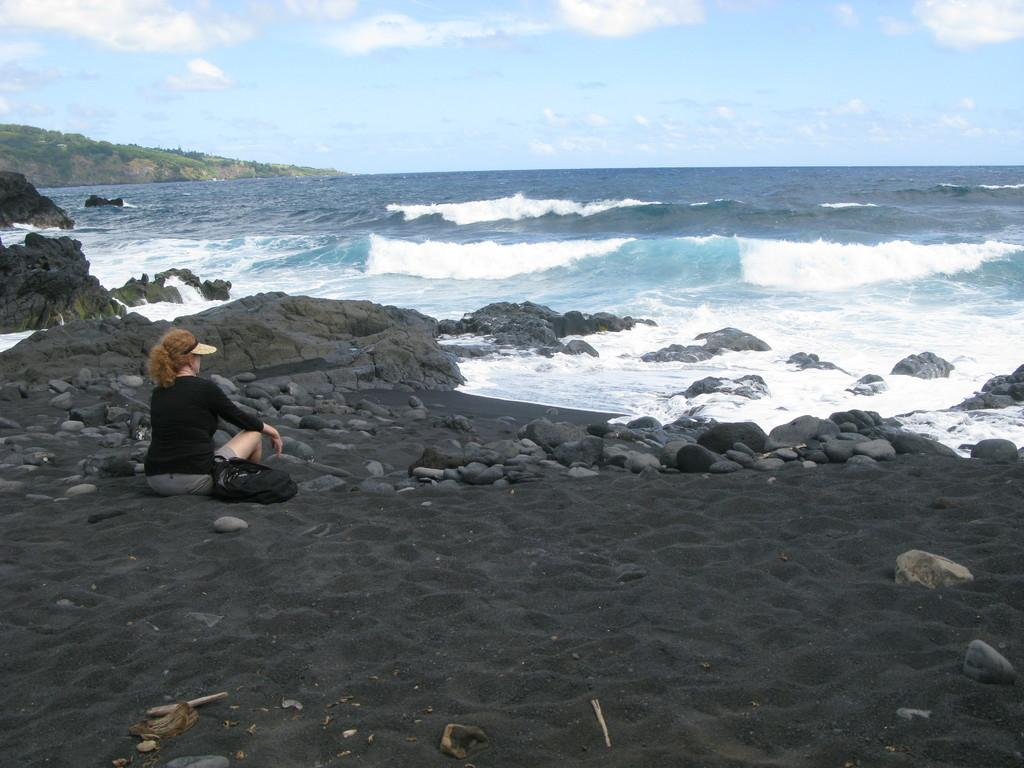Who is the main subject in the foreground of the image? There is a woman in the foreground of the image. What else can be seen in the foreground of the image? There are stones and water in the foreground of the image. What is visible in the background of the image? The background of the image appears to be a mountain, and the sky is visible. What type of flag is flying in the downtown area in the image? There is no flag or downtown area present in the image. 